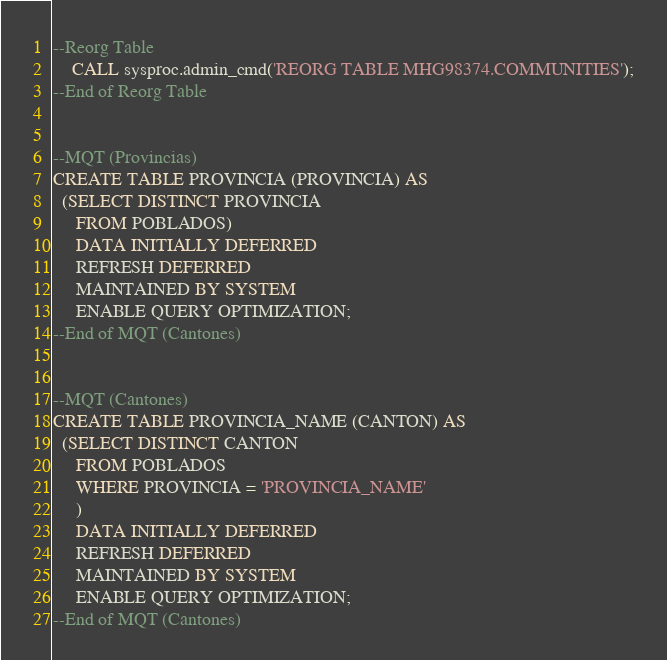Convert code to text. <code><loc_0><loc_0><loc_500><loc_500><_SQL_>--Reorg Table
	CALL sysproc.admin_cmd('REORG TABLE MHG98374.COMMUNITIES');
--End of Reorg Table


--MQT (Provincias)
CREATE TABLE PROVINCIA (PROVINCIA) AS
  (SELECT DISTINCT PROVINCIA
     FROM POBLADOS)
     DATA INITIALLY DEFERRED
     REFRESH DEFERRED
     MAINTAINED BY SYSTEM
     ENABLE QUERY OPTIMIZATION;
--End of MQT (Cantones)


--MQT (Cantones)
CREATE TABLE PROVINCIA_NAME (CANTON) AS
  (SELECT DISTINCT CANTON
     FROM POBLADOS
     WHERE PROVINCIA = 'PROVINCIA_NAME'
     )
     DATA INITIALLY DEFERRED
     REFRESH DEFERRED
     MAINTAINED BY SYSTEM
     ENABLE QUERY OPTIMIZATION;
--End of MQT (Cantones)

</code> 